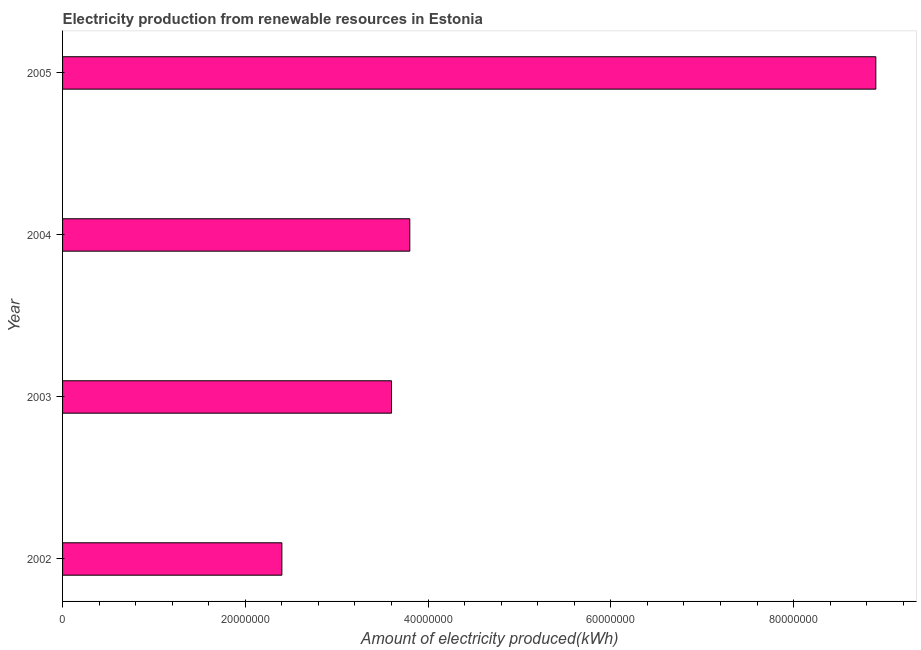Does the graph contain any zero values?
Give a very brief answer. No. Does the graph contain grids?
Your answer should be very brief. No. What is the title of the graph?
Make the answer very short. Electricity production from renewable resources in Estonia. What is the label or title of the X-axis?
Make the answer very short. Amount of electricity produced(kWh). What is the label or title of the Y-axis?
Provide a succinct answer. Year. What is the amount of electricity produced in 2004?
Give a very brief answer. 3.80e+07. Across all years, what is the maximum amount of electricity produced?
Provide a succinct answer. 8.90e+07. Across all years, what is the minimum amount of electricity produced?
Your answer should be very brief. 2.40e+07. What is the sum of the amount of electricity produced?
Provide a short and direct response. 1.87e+08. What is the difference between the amount of electricity produced in 2002 and 2004?
Provide a short and direct response. -1.40e+07. What is the average amount of electricity produced per year?
Make the answer very short. 4.68e+07. What is the median amount of electricity produced?
Your answer should be very brief. 3.70e+07. Do a majority of the years between 2002 and 2004 (inclusive) have amount of electricity produced greater than 32000000 kWh?
Your response must be concise. Yes. What is the ratio of the amount of electricity produced in 2002 to that in 2004?
Keep it short and to the point. 0.63. Is the difference between the amount of electricity produced in 2002 and 2003 greater than the difference between any two years?
Provide a short and direct response. No. What is the difference between the highest and the second highest amount of electricity produced?
Your answer should be very brief. 5.10e+07. What is the difference between the highest and the lowest amount of electricity produced?
Provide a short and direct response. 6.50e+07. How many bars are there?
Your answer should be compact. 4. Are all the bars in the graph horizontal?
Offer a terse response. Yes. What is the difference between two consecutive major ticks on the X-axis?
Provide a short and direct response. 2.00e+07. Are the values on the major ticks of X-axis written in scientific E-notation?
Your response must be concise. No. What is the Amount of electricity produced(kWh) in 2002?
Provide a short and direct response. 2.40e+07. What is the Amount of electricity produced(kWh) of 2003?
Your response must be concise. 3.60e+07. What is the Amount of electricity produced(kWh) in 2004?
Keep it short and to the point. 3.80e+07. What is the Amount of electricity produced(kWh) of 2005?
Ensure brevity in your answer.  8.90e+07. What is the difference between the Amount of electricity produced(kWh) in 2002 and 2003?
Offer a very short reply. -1.20e+07. What is the difference between the Amount of electricity produced(kWh) in 2002 and 2004?
Give a very brief answer. -1.40e+07. What is the difference between the Amount of electricity produced(kWh) in 2002 and 2005?
Offer a very short reply. -6.50e+07. What is the difference between the Amount of electricity produced(kWh) in 2003 and 2005?
Your answer should be very brief. -5.30e+07. What is the difference between the Amount of electricity produced(kWh) in 2004 and 2005?
Offer a terse response. -5.10e+07. What is the ratio of the Amount of electricity produced(kWh) in 2002 to that in 2003?
Give a very brief answer. 0.67. What is the ratio of the Amount of electricity produced(kWh) in 2002 to that in 2004?
Your response must be concise. 0.63. What is the ratio of the Amount of electricity produced(kWh) in 2002 to that in 2005?
Provide a succinct answer. 0.27. What is the ratio of the Amount of electricity produced(kWh) in 2003 to that in 2004?
Ensure brevity in your answer.  0.95. What is the ratio of the Amount of electricity produced(kWh) in 2003 to that in 2005?
Your answer should be compact. 0.4. What is the ratio of the Amount of electricity produced(kWh) in 2004 to that in 2005?
Provide a succinct answer. 0.43. 